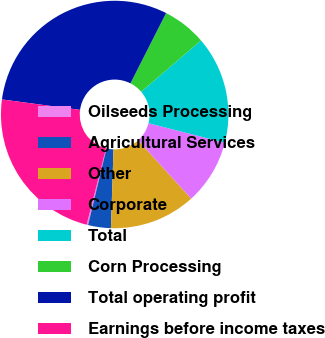<chart> <loc_0><loc_0><loc_500><loc_500><pie_chart><fcel>Oilseeds Processing<fcel>Agricultural Services<fcel>Other<fcel>Corporate<fcel>Total<fcel>Corn Processing<fcel>Total operating profit<fcel>Earnings before income taxes<nl><fcel>0.21%<fcel>3.23%<fcel>12.27%<fcel>9.26%<fcel>15.29%<fcel>6.24%<fcel>30.36%<fcel>23.15%<nl></chart> 